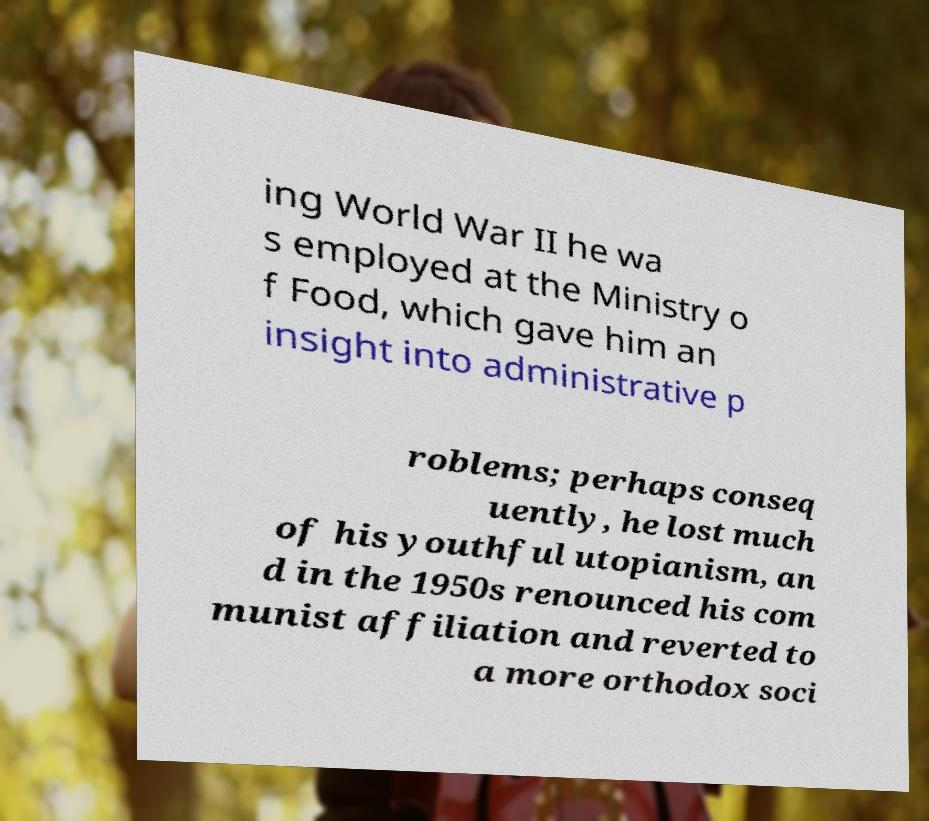Could you extract and type out the text from this image? ing World War II he wa s employed at the Ministry o f Food, which gave him an insight into administrative p roblems; perhaps conseq uently, he lost much of his youthful utopianism, an d in the 1950s renounced his com munist affiliation and reverted to a more orthodox soci 